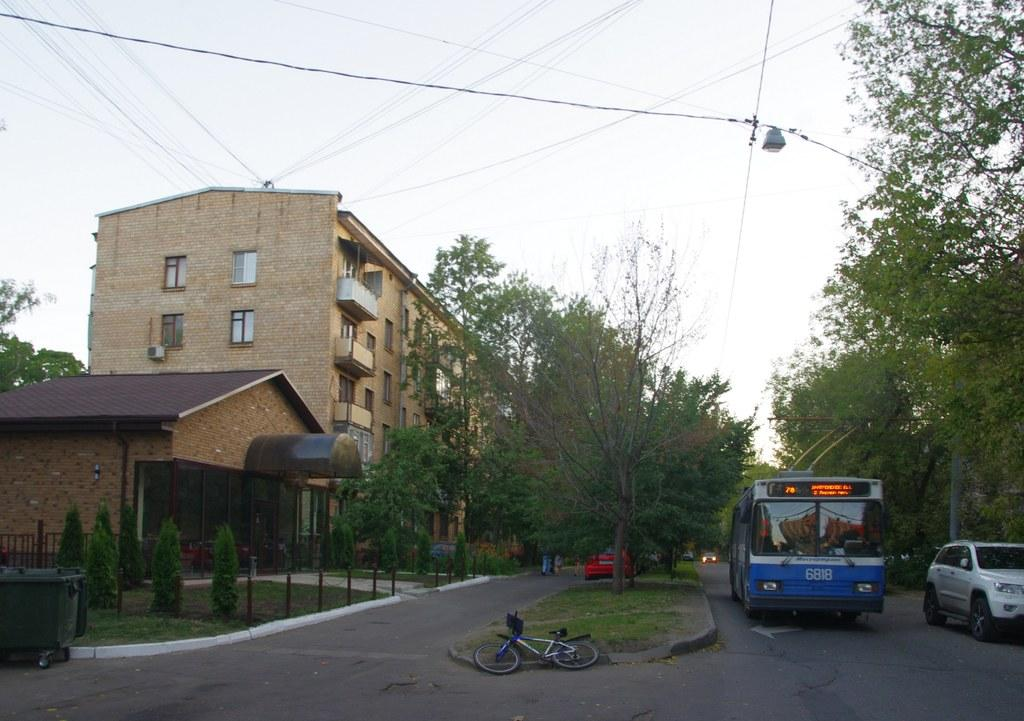What structure is located on the left side of the image? There is a building on the left side of the image. What type of natural elements can be seen in the middle of the image? There are trees in the middle of the image. What is visible at the top of the image? The sky is visible at the top of the image. What type of man-made objects can be seen on the right side of the image? There are vehicles on the right side of the image. Where are the trousers hanging in the image? There are no trousers present in the image. What type of school can be seen in the image? There is no school present in the image. 